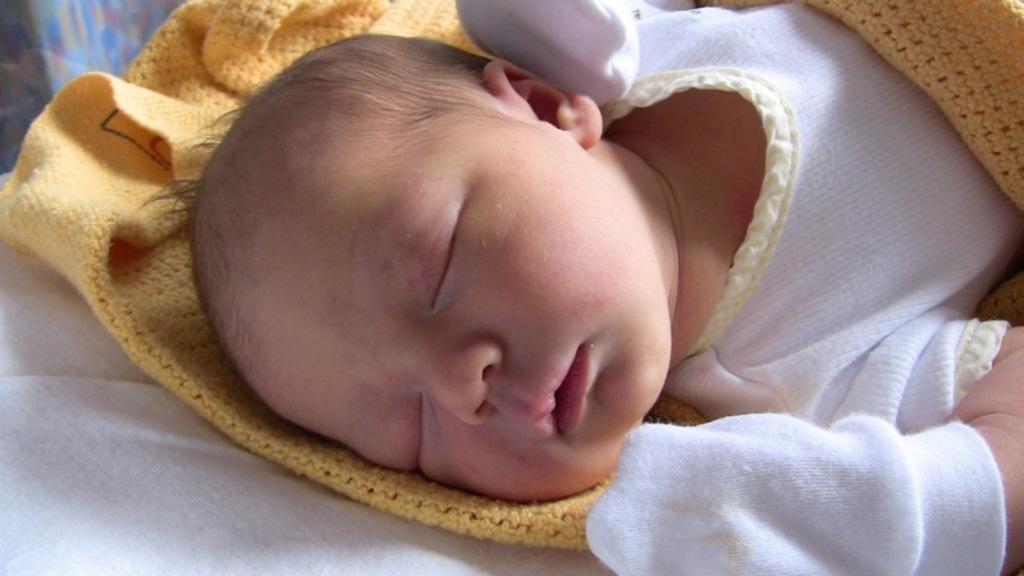What is the main subject of the image? There is a baby in the image. What is the baby wearing? The baby is wearing a white dress. What is the baby lying on? The baby is lying on a cloth. What type of accessory is the baby wearing on their hands? The baby is wearing gloves. What thrilling activity is the baby participating in while wearing gloves? There is no indication of any thrilling activity in the image; the baby is simply lying on a cloth. 